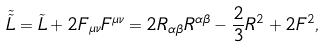<formula> <loc_0><loc_0><loc_500><loc_500>\tilde { \tilde { L } } = \tilde { L } + 2 F _ { \mu \nu } F ^ { \mu \nu } = 2 R _ { \alpha \beta } R ^ { \alpha \beta } - \frac { 2 } { 3 } R ^ { 2 } + 2 F ^ { 2 } ,</formula> 